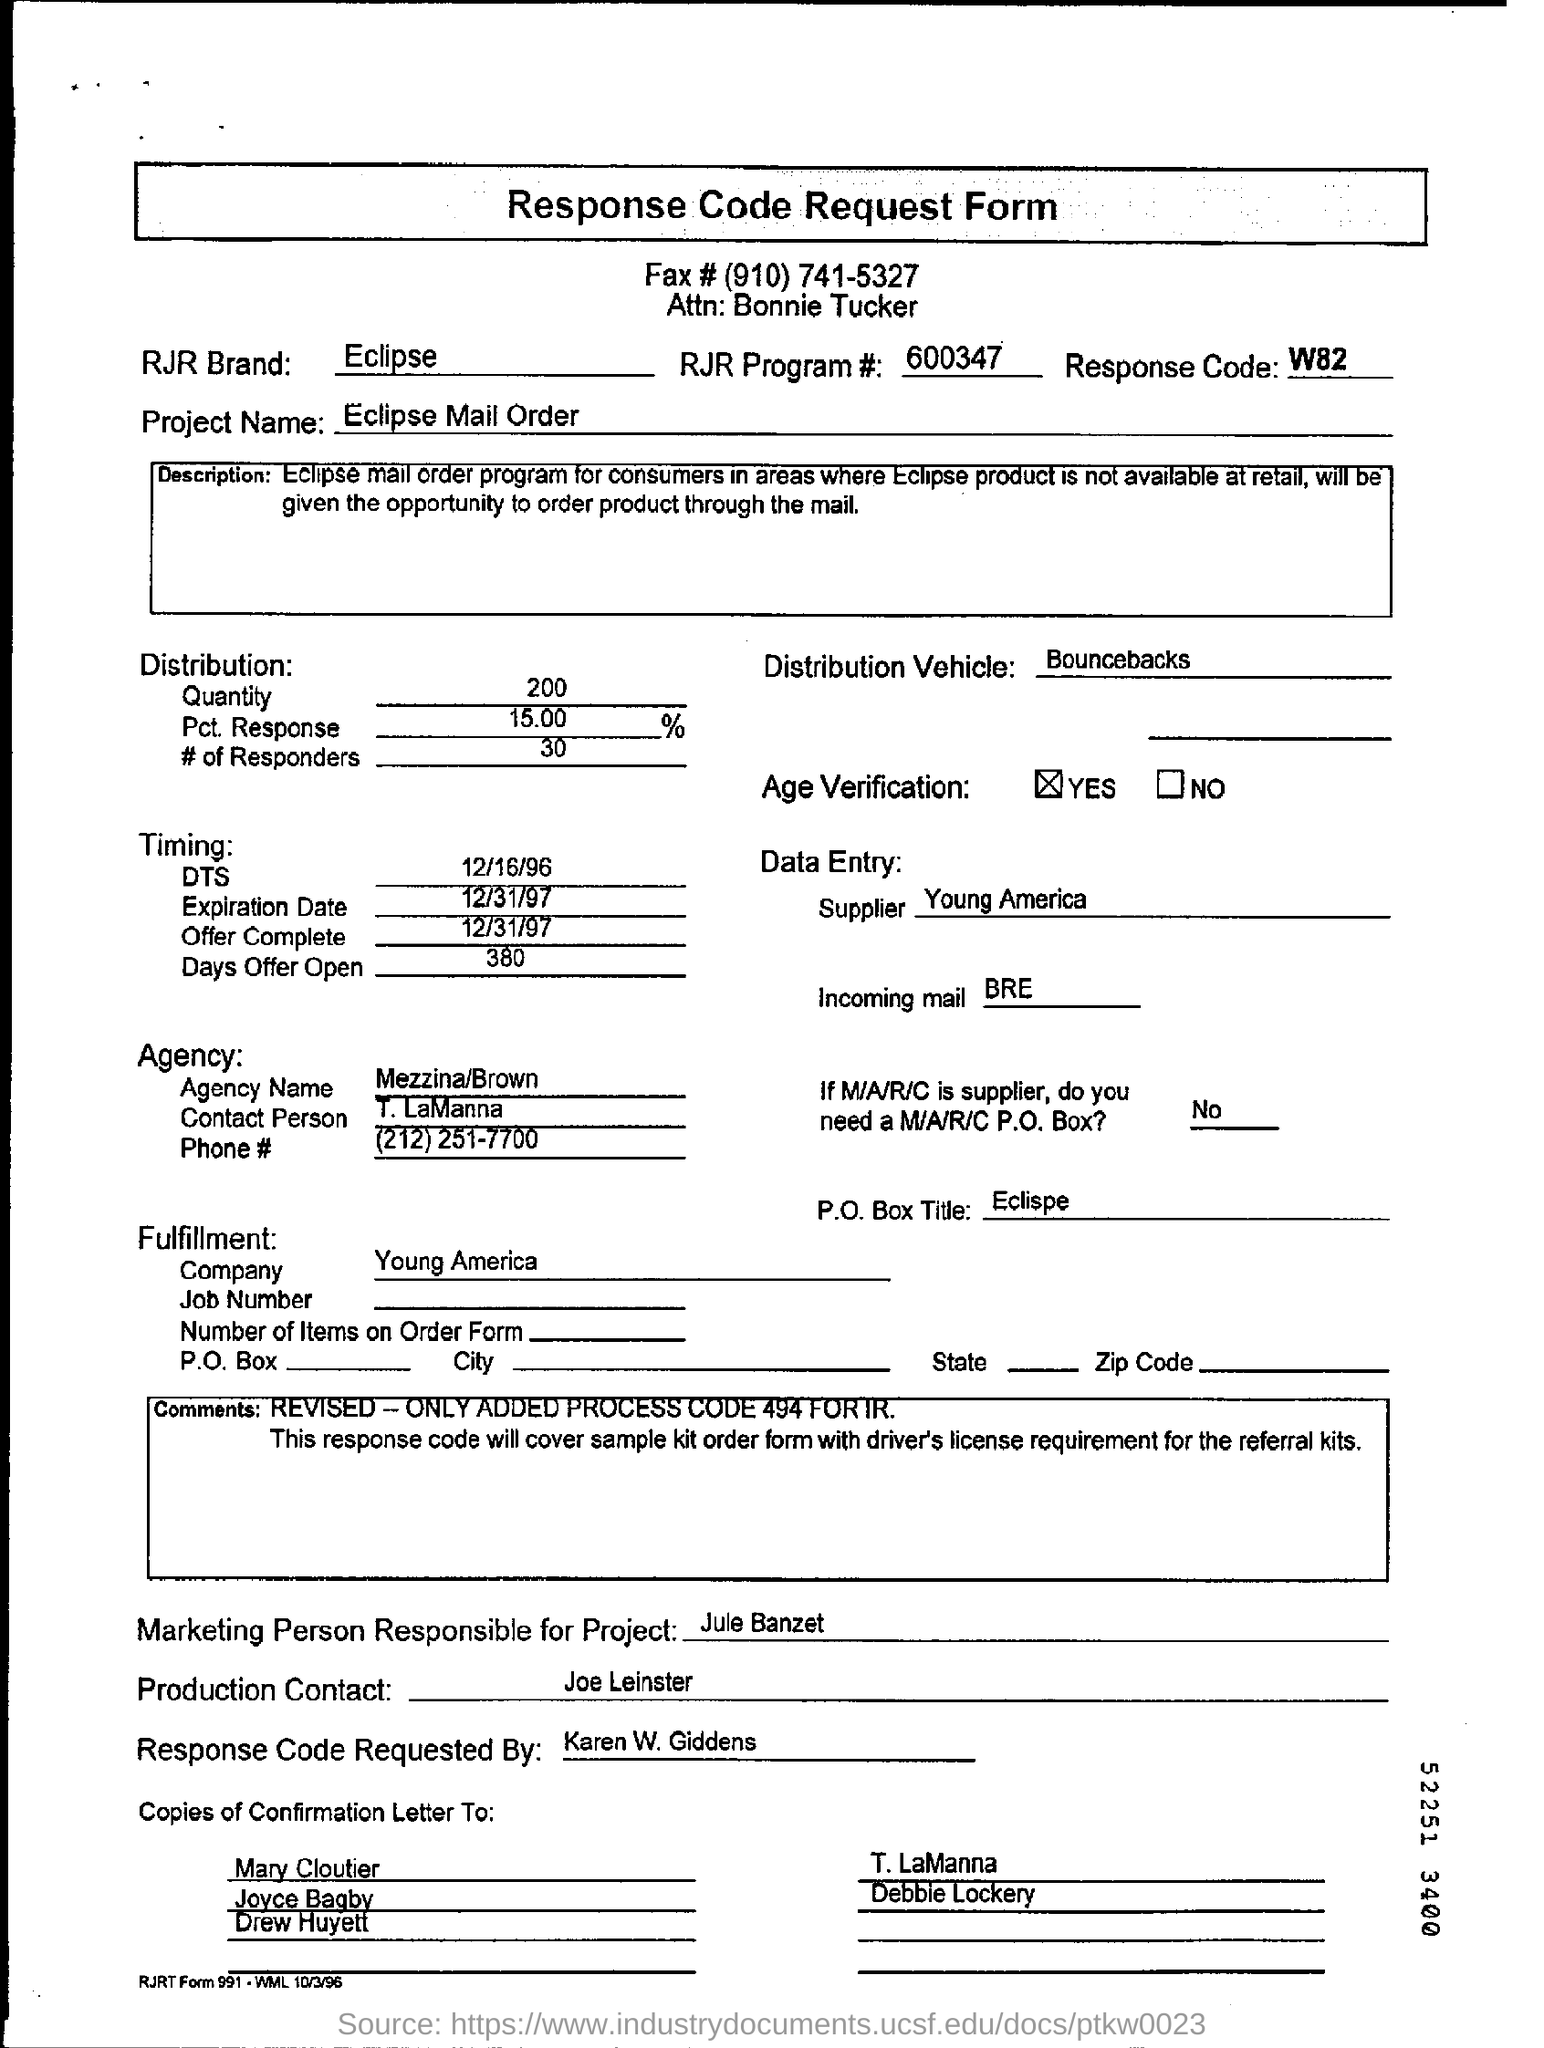Identify some key points in this picture. Young America is the name of the company. The Eclipse Mail Order project is a. The RJR program number is 600347.... The response code is a numerical value that indicates the outcome of a request made to a server. 